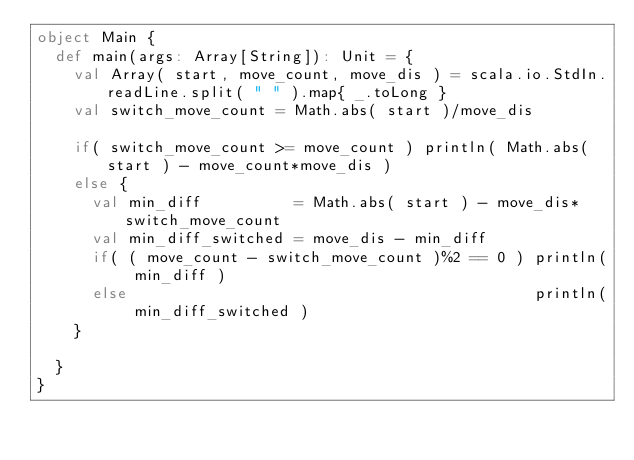Convert code to text. <code><loc_0><loc_0><loc_500><loc_500><_Scala_>object Main {
  def main(args: Array[String]): Unit = {
    val Array( start, move_count, move_dis ) = scala.io.StdIn.readLine.split( " " ).map{ _.toLong }
    val switch_move_count = Math.abs( start )/move_dis

    if( switch_move_count >= move_count ) println( Math.abs( start ) - move_count*move_dis )
    else {
      val min_diff          = Math.abs( start ) - move_dis*switch_move_count
      val min_diff_switched = move_dis - min_diff
      if( ( move_count - switch_move_count )%2 == 0 ) println( min_diff )
      else                                            println( min_diff_switched )
    }

  }
}</code> 